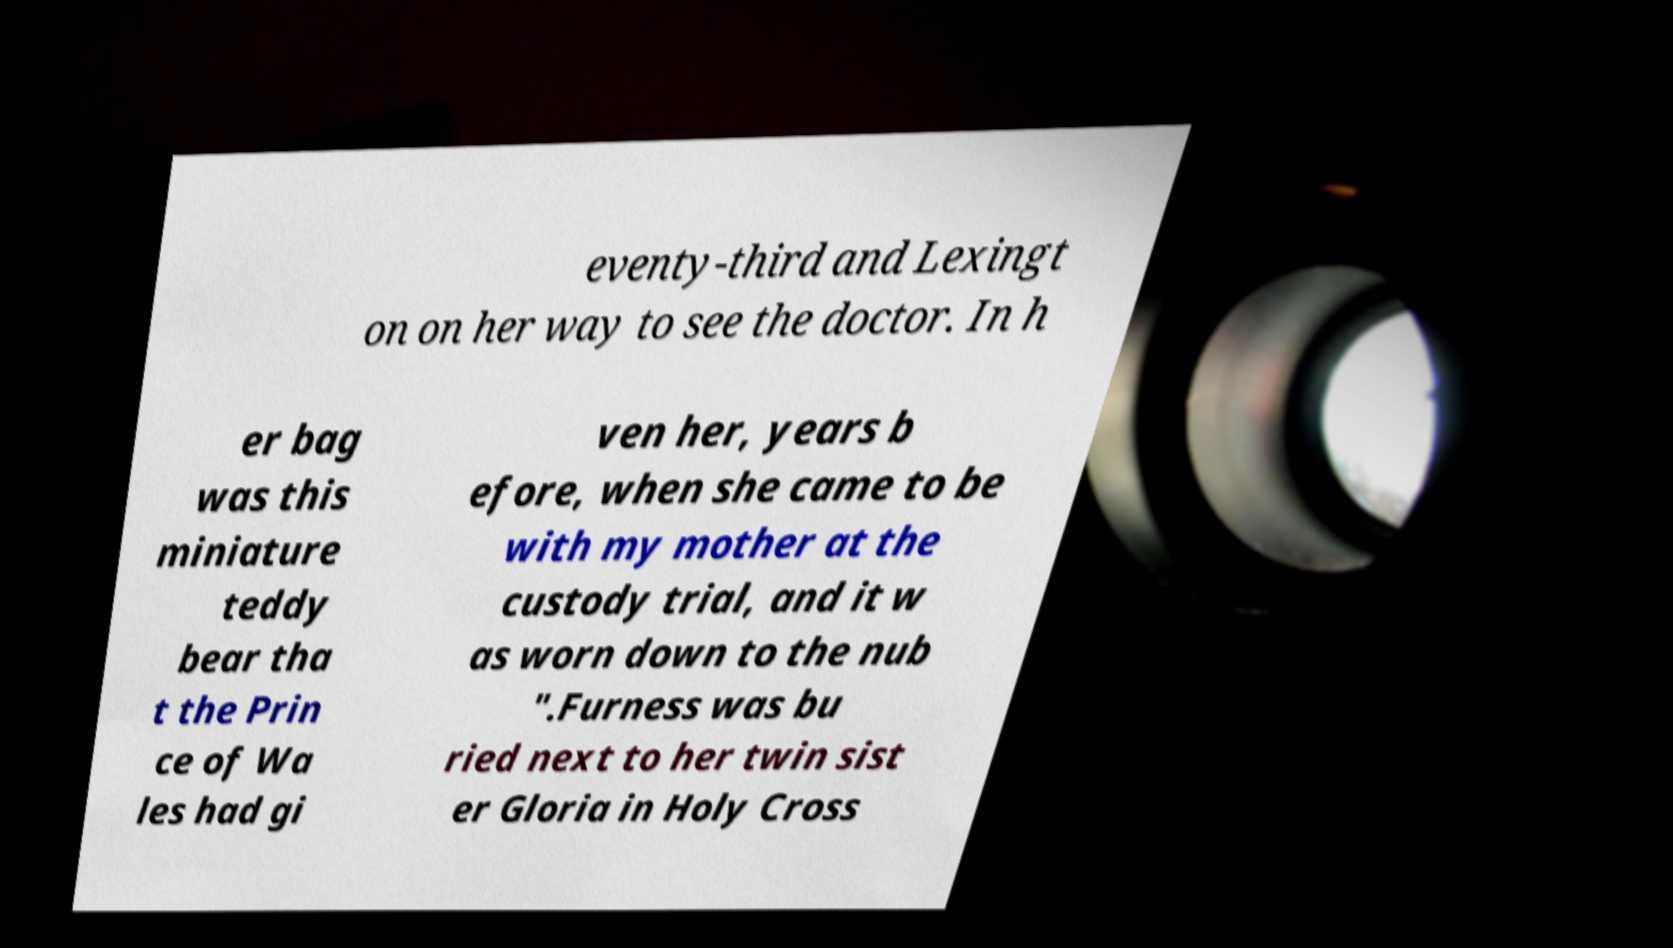Please read and relay the text visible in this image. What does it say? eventy-third and Lexingt on on her way to see the doctor. In h er bag was this miniature teddy bear tha t the Prin ce of Wa les had gi ven her, years b efore, when she came to be with my mother at the custody trial, and it w as worn down to the nub ".Furness was bu ried next to her twin sist er Gloria in Holy Cross 